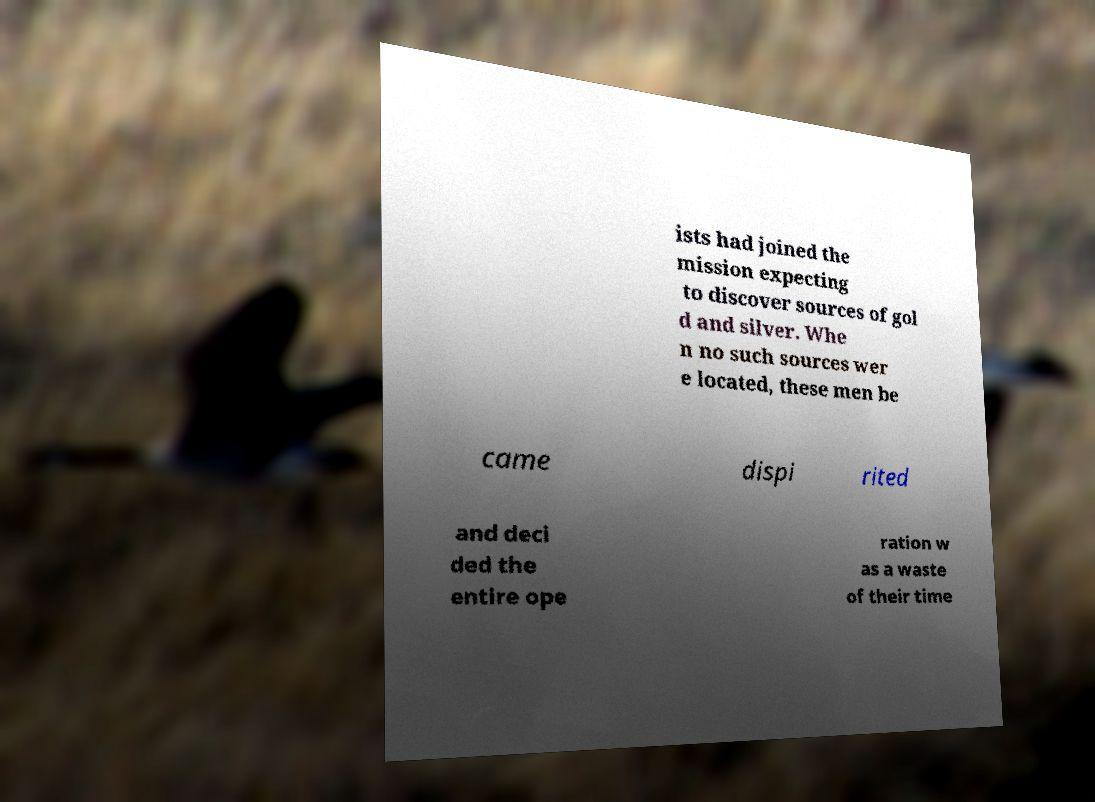What messages or text are displayed in this image? I need them in a readable, typed format. ists had joined the mission expecting to discover sources of gol d and silver. Whe n no such sources wer e located, these men be came dispi rited and deci ded the entire ope ration w as a waste of their time 